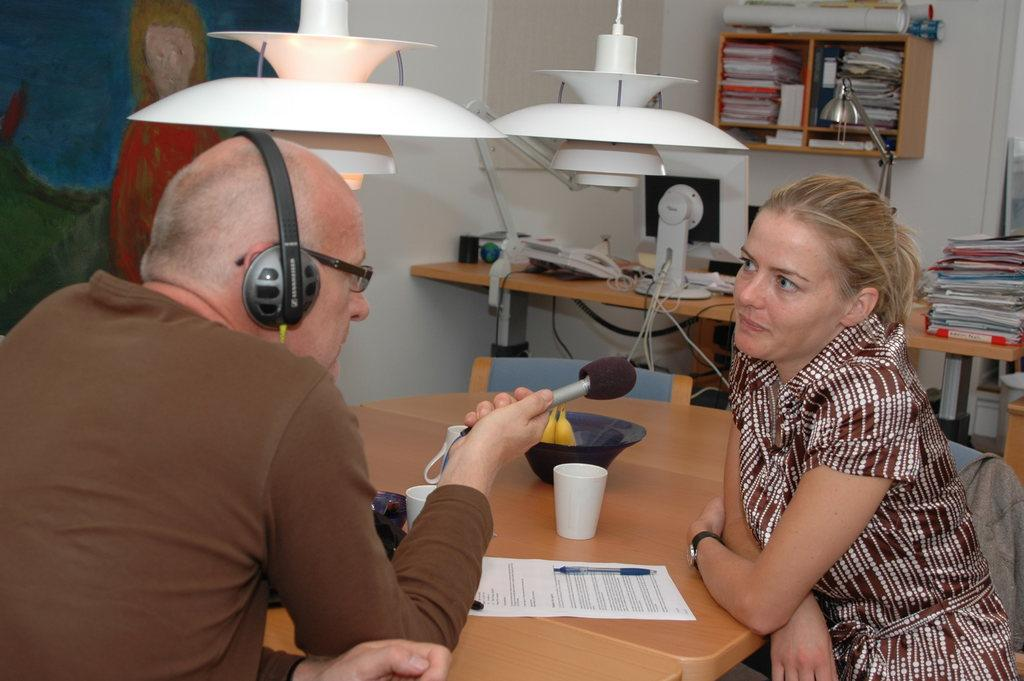How many people are present in the image? There are two people in the image. What can be seen on the table in the image? There are objects on the table in the image. What is visible in the background of the image? There are books in the shelf in the background of the image. How many bricks are stacked on the table in the image? There is no mention of bricks in the image, so it is not possible to determine how many bricks are stacked on the table. 